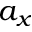Convert formula to latex. <formula><loc_0><loc_0><loc_500><loc_500>a _ { x }</formula> 